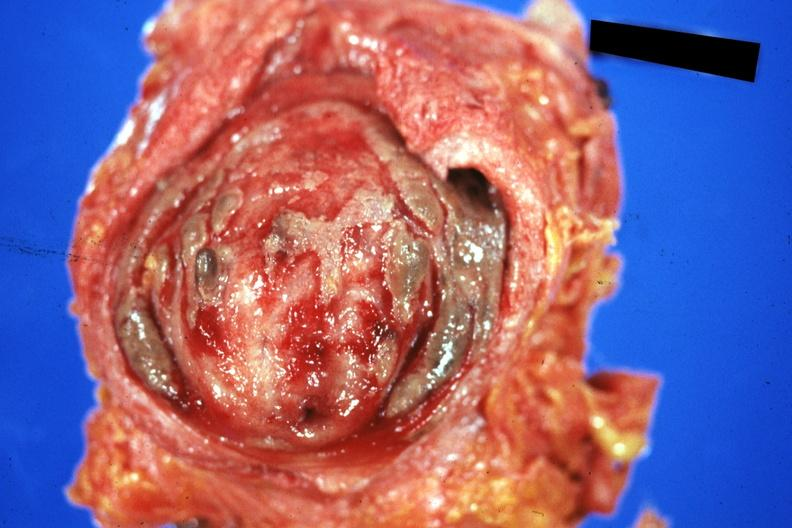does this image show mucosal surface quite good?
Answer the question using a single word or phrase. Yes 